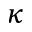Convert formula to latex. <formula><loc_0><loc_0><loc_500><loc_500>\kappa</formula> 